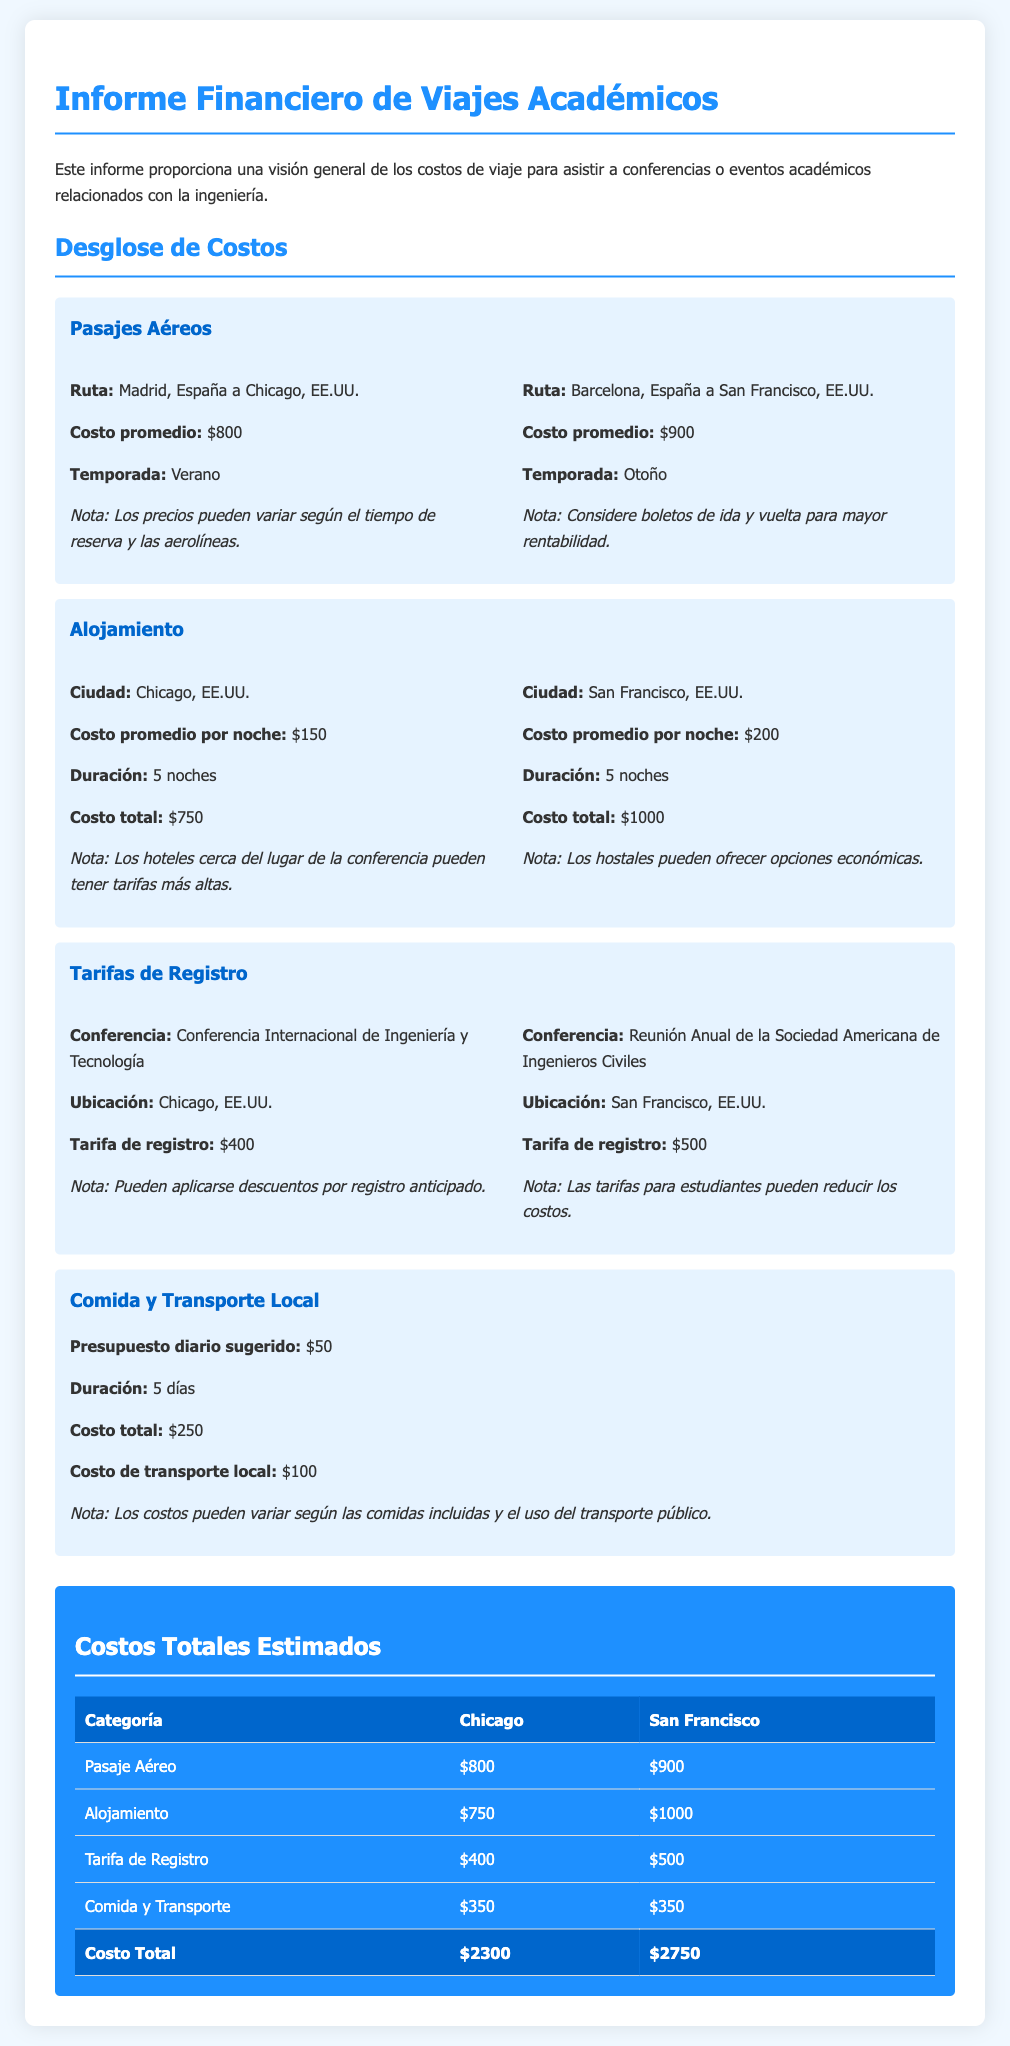¿Cuál es el costo promedio del pasaje aéreo de Madrid a Chicago? El costo promedio del pasaje aéreo de Madrid a Chicago es de $800, según el desglose de costos.
Answer: $800 ¿Cuál es el costo total de alojamiento en San Francisco por 5 noches? El costo promedio por noche en San Francisco es de $200, lo que hace un total de $1000 por 5 noches.
Answer: $1000 ¿Qué conferencia se menciona en relación a Chicago? La conferencia mencionada en relación a Chicago es la Conferencia Internacional de Ingeniería y Tecnología, con una tarifa de registro de $400.
Answer: Conferencia Internacional de Ingeniería y Tecnología ¿Cuál es el costo total estimado para asistir a la conferencia en Chicago? La suma de todos los costos en Chicago es de $2300.
Answer: $2300 ¿Cuál es el presupuesto diario sugerido para comida? El presupuesto diario sugerido para comida es de $50, como se indica en la sección de Comida y Transporte Local.
Answer: $50 ¿Cuánto cuesta la tarifa de registro para la reunión anual en San Francisco? La tarifa de registro para la reunión anual de la Sociedad Americana de Ingenieros Civiles es de $500.
Answer: $500 ¿Cuánto se estima para transporte local en total? El costo total estimado para transporte local es de $100, mencionado en la sección de Comida y Transporte Local.
Answer: $100 ¿Qué ruta tiene el costo de pasaje aéreo más alto? La ruta de Barcelona a San Francisco tiene un costo promedio de $900, siendo la más alta en comparación con la de Madrid a Chicago.
Answer: Barcelona, España a San Francisco ¿Cuántos días de duración se considera en el presupuesto de comida? La duración considerada en el presupuesto de comida es de 5 días.
Answer: 5 días 